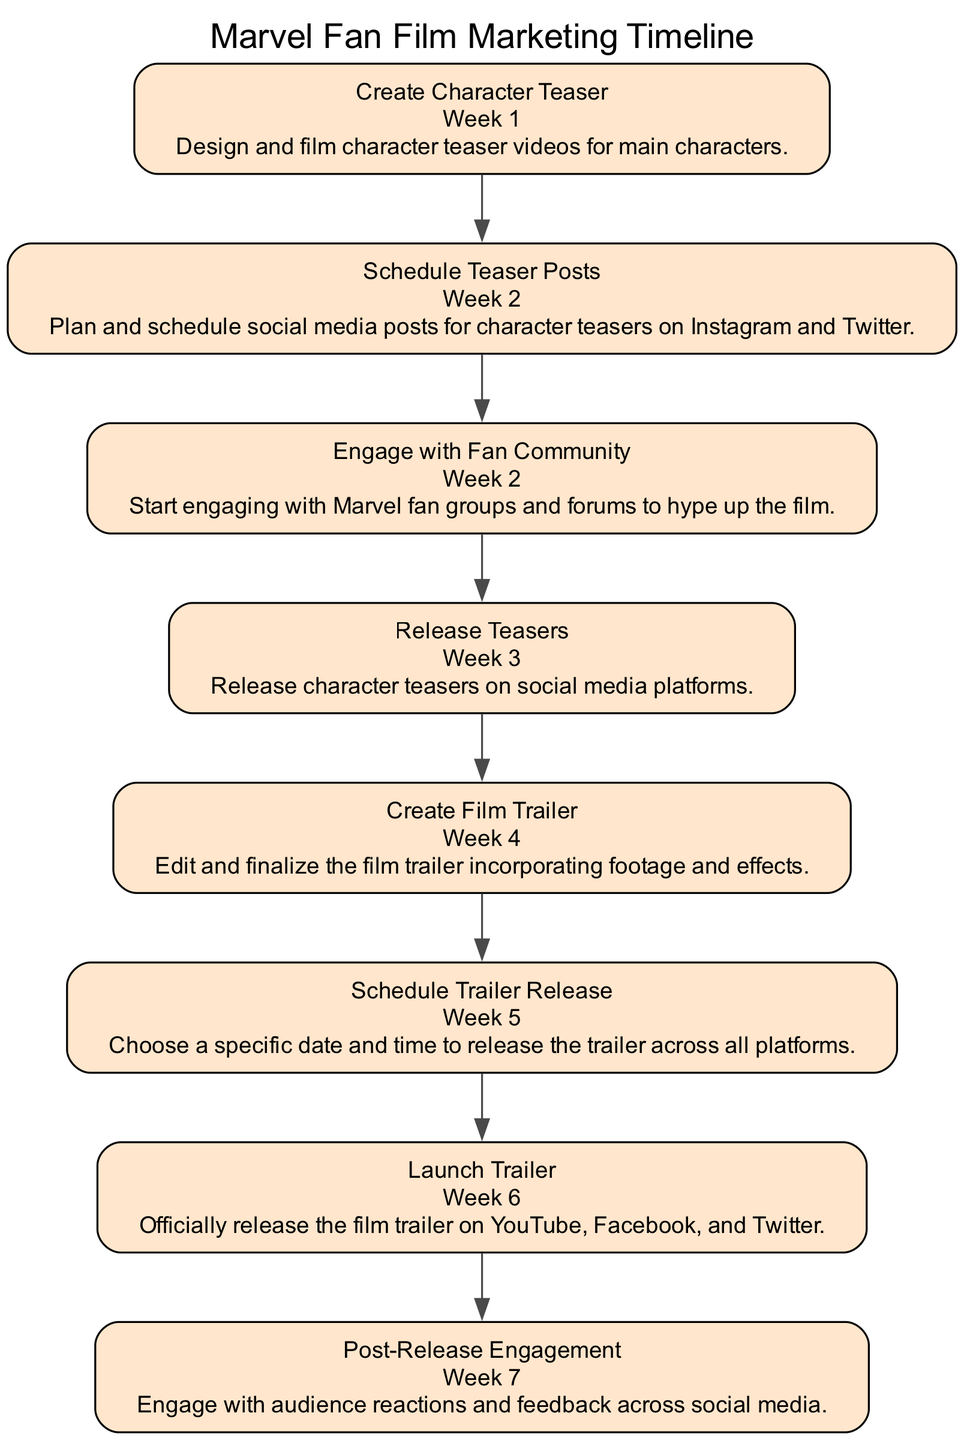What is the first event in the timeline? The timeline starts with the event "Create Character Teaser," which is listed as occurring in Week 1. This is the first node in the sequence.
Answer: Create Character Teaser How many total events are there in the diagram? By counting each event node in the sequence diagram, we find there are 8 distinct events total.
Answer: 8 What is the date of the "Launch Trailer" event? The "Launch Trailer" event is scheduled for Week 6, which is specifically indicated in the respective node.
Answer: Week 6 Which two events are scheduled in Week 2? The diagram shows "Schedule Teaser Posts" and "Engage with Fan Community" occurring in Week 2. Both events are annotated with the same date.
Answer: Schedule Teaser Posts, Engage with Fan Community What is the last event in the timeline? The final event in the timeline is "Post-Release Engagement," occurring in Week 7. It is clearly indicated as the last node.
Answer: Post-Release Engagement Which event directly follows the "Release Teasers" event? The "Create Film Trailer" event directly follows "Release Teasers," as they are connected sequentially in the diagram.
Answer: Create Film Trailer How many weeks are there between "Create Character Teaser" and "Launch Trailer"? Between the "Create Character Teaser" (Week 1) and "Launch Trailer" (Week 6), there are a total of 5 weeks. This is derived from counting the timeline intervals.
Answer: 5 weeks What is the purpose of the "Engage with Fan Community" event? The purpose of "Engage with Fan Community" is to start interacting with Marvel fan groups and forums for promoting awareness of the film. This is specified in the event details.
Answer: Engaging with Marvel fan groups and forums What are the platforms used in the "Launch Trailer" event? The platforms specified for the "Launch Trailer" event include YouTube, Facebook, and Twitter. This is explicitly listed in the event's details.
Answer: YouTube, Facebook, Twitter 